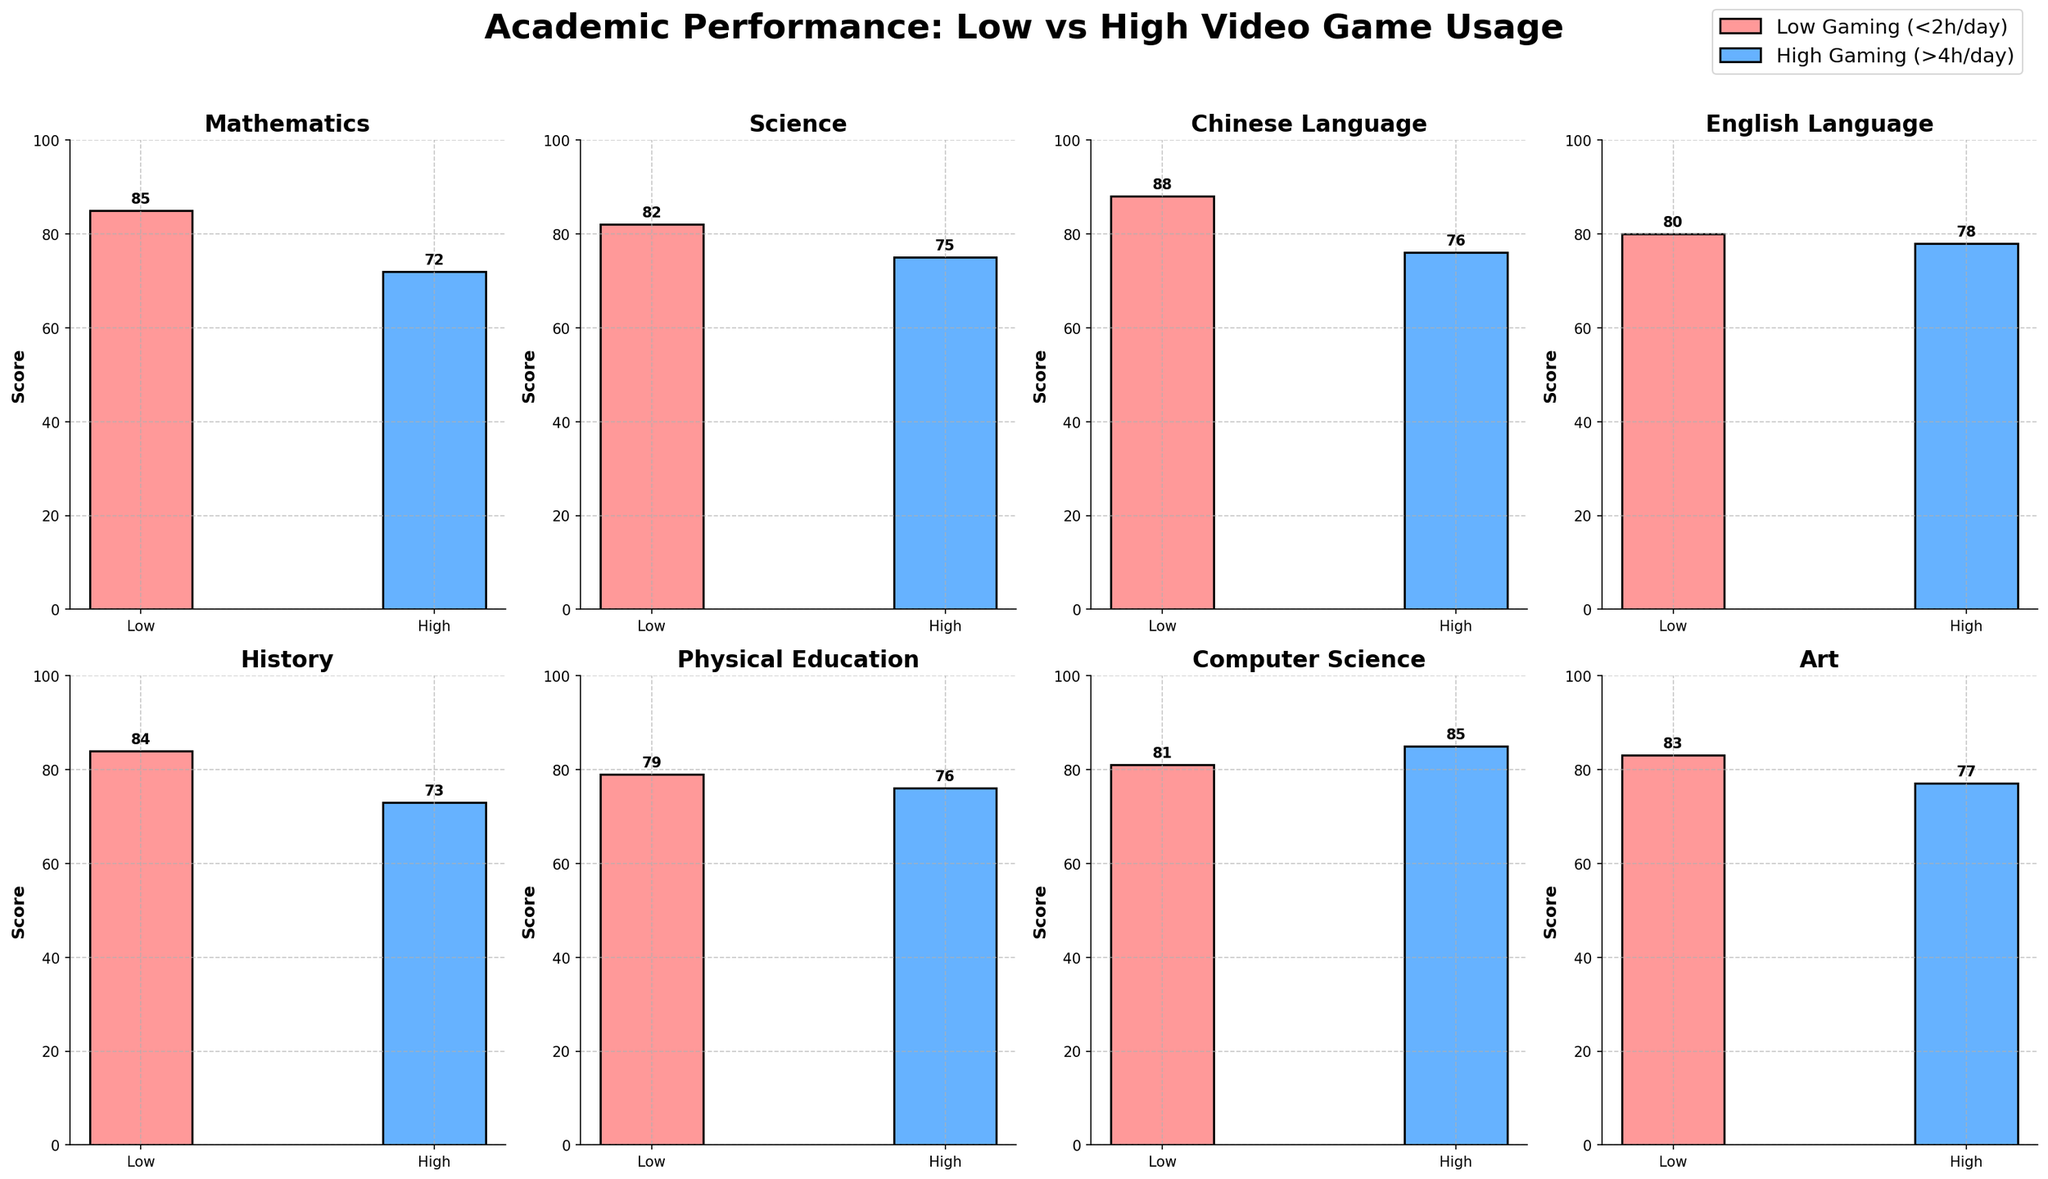What is the title of the figure? The title of the figure is displayed prominently at the top. It reads "Academic Performance: Low vs High Video Game Usage."
Answer: Academic Performance: Low vs High Video Game Usage Which subject shows the highest score for children with low video game usage? Look at the bar heights for each subject under "Low Gaming (<2h/day)." The highest bar corresponds to the Chinese Language subject with a score of 88.
Answer: Chinese Language What is the score difference in Mathematics between children with low and high video game usage? For Mathematics, the bar for low gaming is at 85 and for high gaming is at 72. Subtracting these, 85 - 72, gives the score difference.
Answer: 13 In which subject do children with high video game usage score higher than children with low video game usage? Compare the bar heights for each subject. Only in Computer Science do children with high video game usage (85) score higher than those with low video game usage (81).
Answer: Computer Science What is the average score for children with low video game usage across all subjects? Sum the scores from low video game usage across all subjects: 85 + 82 + 88 + 80 + 84 + 79 + 81 + 83 = 662. There are 8 subjects, so the average is 662/8.
Answer: 82.75 Which subject has the smallest score difference between low and high video game usage? Calculate the score differences for all subjects, e.g., Mathematics (13), Science (7), Chinese Language (12), etc. The smallest difference is in English Language with a difference of 2 (80 - 78).
Answer: English Language How many subjects have lower scores for children with high video game usage compared to low video game usage? Count the subjects where the low gaming bar is higher than the high gaming bar. There are 7 such subjects: Mathematics, Science, Chinese Language, History, Physical Education, Art, and English Language.
Answer: 7 